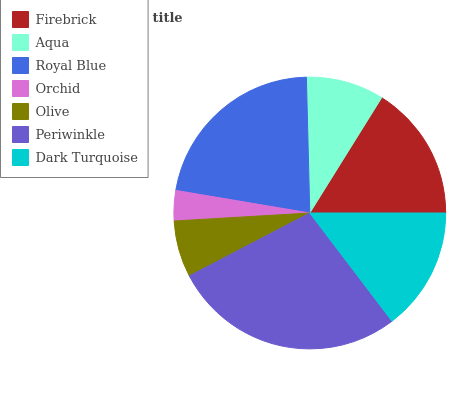Is Orchid the minimum?
Answer yes or no. Yes. Is Periwinkle the maximum?
Answer yes or no. Yes. Is Aqua the minimum?
Answer yes or no. No. Is Aqua the maximum?
Answer yes or no. No. Is Firebrick greater than Aqua?
Answer yes or no. Yes. Is Aqua less than Firebrick?
Answer yes or no. Yes. Is Aqua greater than Firebrick?
Answer yes or no. No. Is Firebrick less than Aqua?
Answer yes or no. No. Is Dark Turquoise the high median?
Answer yes or no. Yes. Is Dark Turquoise the low median?
Answer yes or no. Yes. Is Periwinkle the high median?
Answer yes or no. No. Is Orchid the low median?
Answer yes or no. No. 